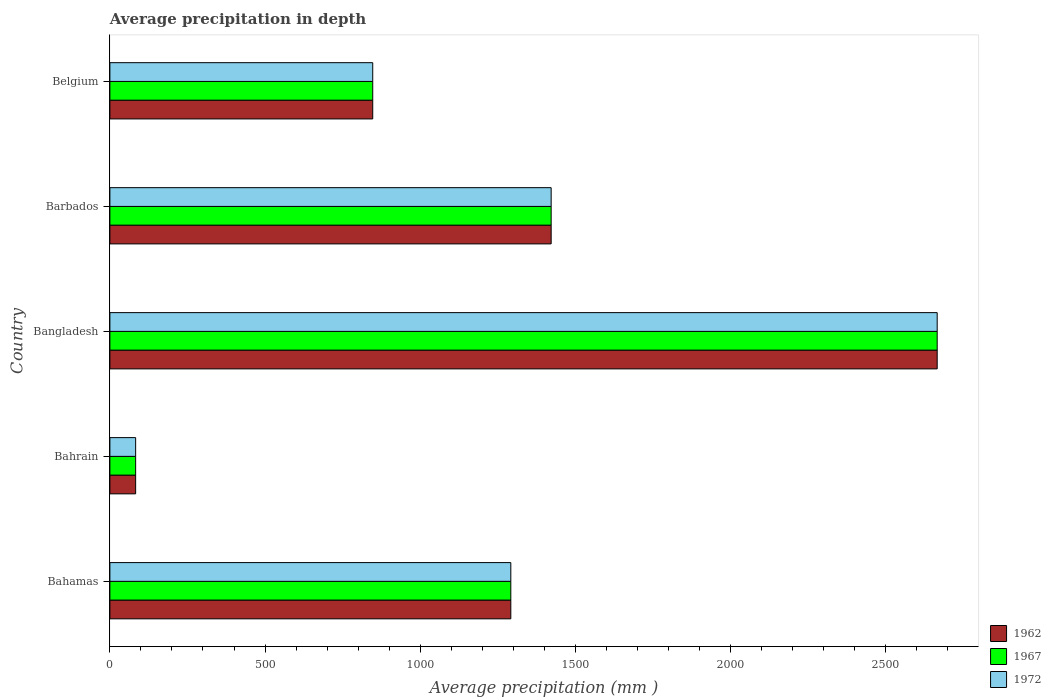How many different coloured bars are there?
Keep it short and to the point. 3. How many groups of bars are there?
Your response must be concise. 5. Are the number of bars on each tick of the Y-axis equal?
Your answer should be very brief. Yes. How many bars are there on the 2nd tick from the top?
Offer a very short reply. 3. How many bars are there on the 5th tick from the bottom?
Ensure brevity in your answer.  3. What is the label of the 5th group of bars from the top?
Your answer should be compact. Bahamas. In how many cases, is the number of bars for a given country not equal to the number of legend labels?
Offer a very short reply. 0. Across all countries, what is the maximum average precipitation in 1972?
Keep it short and to the point. 2666. Across all countries, what is the minimum average precipitation in 1972?
Provide a succinct answer. 83. In which country was the average precipitation in 1972 minimum?
Offer a very short reply. Bahrain. What is the total average precipitation in 1967 in the graph?
Make the answer very short. 6310. What is the difference between the average precipitation in 1962 in Bahamas and that in Belgium?
Your answer should be very brief. 445. What is the difference between the average precipitation in 1962 in Bangladesh and the average precipitation in 1972 in Bahamas?
Your response must be concise. 1374. What is the average average precipitation in 1967 per country?
Ensure brevity in your answer.  1262. What is the difference between the average precipitation in 1967 and average precipitation in 1972 in Bangladesh?
Offer a very short reply. 0. In how many countries, is the average precipitation in 1962 greater than 300 mm?
Your answer should be very brief. 4. What is the ratio of the average precipitation in 1962 in Barbados to that in Belgium?
Offer a terse response. 1.68. What is the difference between the highest and the second highest average precipitation in 1972?
Provide a short and direct response. 1244. What is the difference between the highest and the lowest average precipitation in 1962?
Provide a short and direct response. 2583. In how many countries, is the average precipitation in 1967 greater than the average average precipitation in 1967 taken over all countries?
Make the answer very short. 3. What does the 2nd bar from the top in Bahrain represents?
Give a very brief answer. 1967. What does the 1st bar from the bottom in Bangladesh represents?
Provide a short and direct response. 1962. How many bars are there?
Provide a short and direct response. 15. How many countries are there in the graph?
Give a very brief answer. 5. Does the graph contain grids?
Your answer should be very brief. No. Where does the legend appear in the graph?
Ensure brevity in your answer.  Bottom right. What is the title of the graph?
Make the answer very short. Average precipitation in depth. What is the label or title of the X-axis?
Ensure brevity in your answer.  Average precipitation (mm ). What is the label or title of the Y-axis?
Offer a terse response. Country. What is the Average precipitation (mm ) in 1962 in Bahamas?
Your response must be concise. 1292. What is the Average precipitation (mm ) of 1967 in Bahamas?
Make the answer very short. 1292. What is the Average precipitation (mm ) in 1972 in Bahamas?
Keep it short and to the point. 1292. What is the Average precipitation (mm ) of 1967 in Bahrain?
Offer a terse response. 83. What is the Average precipitation (mm ) in 1962 in Bangladesh?
Give a very brief answer. 2666. What is the Average precipitation (mm ) of 1967 in Bangladesh?
Keep it short and to the point. 2666. What is the Average precipitation (mm ) in 1972 in Bangladesh?
Ensure brevity in your answer.  2666. What is the Average precipitation (mm ) in 1962 in Barbados?
Give a very brief answer. 1422. What is the Average precipitation (mm ) in 1967 in Barbados?
Your answer should be very brief. 1422. What is the Average precipitation (mm ) in 1972 in Barbados?
Ensure brevity in your answer.  1422. What is the Average precipitation (mm ) in 1962 in Belgium?
Provide a short and direct response. 847. What is the Average precipitation (mm ) in 1967 in Belgium?
Ensure brevity in your answer.  847. What is the Average precipitation (mm ) of 1972 in Belgium?
Your response must be concise. 847. Across all countries, what is the maximum Average precipitation (mm ) in 1962?
Keep it short and to the point. 2666. Across all countries, what is the maximum Average precipitation (mm ) of 1967?
Provide a short and direct response. 2666. Across all countries, what is the maximum Average precipitation (mm ) of 1972?
Your answer should be compact. 2666. Across all countries, what is the minimum Average precipitation (mm ) of 1967?
Ensure brevity in your answer.  83. What is the total Average precipitation (mm ) in 1962 in the graph?
Offer a terse response. 6310. What is the total Average precipitation (mm ) of 1967 in the graph?
Keep it short and to the point. 6310. What is the total Average precipitation (mm ) in 1972 in the graph?
Offer a terse response. 6310. What is the difference between the Average precipitation (mm ) of 1962 in Bahamas and that in Bahrain?
Provide a succinct answer. 1209. What is the difference between the Average precipitation (mm ) of 1967 in Bahamas and that in Bahrain?
Keep it short and to the point. 1209. What is the difference between the Average precipitation (mm ) of 1972 in Bahamas and that in Bahrain?
Your answer should be compact. 1209. What is the difference between the Average precipitation (mm ) in 1962 in Bahamas and that in Bangladesh?
Offer a terse response. -1374. What is the difference between the Average precipitation (mm ) in 1967 in Bahamas and that in Bangladesh?
Your answer should be compact. -1374. What is the difference between the Average precipitation (mm ) of 1972 in Bahamas and that in Bangladesh?
Your answer should be very brief. -1374. What is the difference between the Average precipitation (mm ) in 1962 in Bahamas and that in Barbados?
Offer a very short reply. -130. What is the difference between the Average precipitation (mm ) of 1967 in Bahamas and that in Barbados?
Your answer should be compact. -130. What is the difference between the Average precipitation (mm ) in 1972 in Bahamas and that in Barbados?
Ensure brevity in your answer.  -130. What is the difference between the Average precipitation (mm ) in 1962 in Bahamas and that in Belgium?
Offer a very short reply. 445. What is the difference between the Average precipitation (mm ) of 1967 in Bahamas and that in Belgium?
Offer a very short reply. 445. What is the difference between the Average precipitation (mm ) in 1972 in Bahamas and that in Belgium?
Your answer should be compact. 445. What is the difference between the Average precipitation (mm ) of 1962 in Bahrain and that in Bangladesh?
Your response must be concise. -2583. What is the difference between the Average precipitation (mm ) in 1967 in Bahrain and that in Bangladesh?
Ensure brevity in your answer.  -2583. What is the difference between the Average precipitation (mm ) of 1972 in Bahrain and that in Bangladesh?
Your response must be concise. -2583. What is the difference between the Average precipitation (mm ) of 1962 in Bahrain and that in Barbados?
Your answer should be very brief. -1339. What is the difference between the Average precipitation (mm ) of 1967 in Bahrain and that in Barbados?
Keep it short and to the point. -1339. What is the difference between the Average precipitation (mm ) in 1972 in Bahrain and that in Barbados?
Provide a short and direct response. -1339. What is the difference between the Average precipitation (mm ) in 1962 in Bahrain and that in Belgium?
Provide a short and direct response. -764. What is the difference between the Average precipitation (mm ) of 1967 in Bahrain and that in Belgium?
Keep it short and to the point. -764. What is the difference between the Average precipitation (mm ) in 1972 in Bahrain and that in Belgium?
Give a very brief answer. -764. What is the difference between the Average precipitation (mm ) of 1962 in Bangladesh and that in Barbados?
Offer a very short reply. 1244. What is the difference between the Average precipitation (mm ) in 1967 in Bangladesh and that in Barbados?
Your response must be concise. 1244. What is the difference between the Average precipitation (mm ) of 1972 in Bangladesh and that in Barbados?
Your response must be concise. 1244. What is the difference between the Average precipitation (mm ) of 1962 in Bangladesh and that in Belgium?
Your response must be concise. 1819. What is the difference between the Average precipitation (mm ) of 1967 in Bangladesh and that in Belgium?
Keep it short and to the point. 1819. What is the difference between the Average precipitation (mm ) in 1972 in Bangladesh and that in Belgium?
Keep it short and to the point. 1819. What is the difference between the Average precipitation (mm ) in 1962 in Barbados and that in Belgium?
Provide a succinct answer. 575. What is the difference between the Average precipitation (mm ) in 1967 in Barbados and that in Belgium?
Give a very brief answer. 575. What is the difference between the Average precipitation (mm ) of 1972 in Barbados and that in Belgium?
Offer a terse response. 575. What is the difference between the Average precipitation (mm ) in 1962 in Bahamas and the Average precipitation (mm ) in 1967 in Bahrain?
Offer a very short reply. 1209. What is the difference between the Average precipitation (mm ) of 1962 in Bahamas and the Average precipitation (mm ) of 1972 in Bahrain?
Offer a very short reply. 1209. What is the difference between the Average precipitation (mm ) of 1967 in Bahamas and the Average precipitation (mm ) of 1972 in Bahrain?
Provide a short and direct response. 1209. What is the difference between the Average precipitation (mm ) in 1962 in Bahamas and the Average precipitation (mm ) in 1967 in Bangladesh?
Offer a very short reply. -1374. What is the difference between the Average precipitation (mm ) of 1962 in Bahamas and the Average precipitation (mm ) of 1972 in Bangladesh?
Ensure brevity in your answer.  -1374. What is the difference between the Average precipitation (mm ) in 1967 in Bahamas and the Average precipitation (mm ) in 1972 in Bangladesh?
Provide a succinct answer. -1374. What is the difference between the Average precipitation (mm ) in 1962 in Bahamas and the Average precipitation (mm ) in 1967 in Barbados?
Your answer should be compact. -130. What is the difference between the Average precipitation (mm ) in 1962 in Bahamas and the Average precipitation (mm ) in 1972 in Barbados?
Keep it short and to the point. -130. What is the difference between the Average precipitation (mm ) of 1967 in Bahamas and the Average precipitation (mm ) of 1972 in Barbados?
Keep it short and to the point. -130. What is the difference between the Average precipitation (mm ) in 1962 in Bahamas and the Average precipitation (mm ) in 1967 in Belgium?
Give a very brief answer. 445. What is the difference between the Average precipitation (mm ) of 1962 in Bahamas and the Average precipitation (mm ) of 1972 in Belgium?
Make the answer very short. 445. What is the difference between the Average precipitation (mm ) in 1967 in Bahamas and the Average precipitation (mm ) in 1972 in Belgium?
Offer a terse response. 445. What is the difference between the Average precipitation (mm ) in 1962 in Bahrain and the Average precipitation (mm ) in 1967 in Bangladesh?
Give a very brief answer. -2583. What is the difference between the Average precipitation (mm ) in 1962 in Bahrain and the Average precipitation (mm ) in 1972 in Bangladesh?
Your answer should be compact. -2583. What is the difference between the Average precipitation (mm ) in 1967 in Bahrain and the Average precipitation (mm ) in 1972 in Bangladesh?
Keep it short and to the point. -2583. What is the difference between the Average precipitation (mm ) of 1962 in Bahrain and the Average precipitation (mm ) of 1967 in Barbados?
Make the answer very short. -1339. What is the difference between the Average precipitation (mm ) in 1962 in Bahrain and the Average precipitation (mm ) in 1972 in Barbados?
Offer a very short reply. -1339. What is the difference between the Average precipitation (mm ) in 1967 in Bahrain and the Average precipitation (mm ) in 1972 in Barbados?
Your response must be concise. -1339. What is the difference between the Average precipitation (mm ) of 1962 in Bahrain and the Average precipitation (mm ) of 1967 in Belgium?
Give a very brief answer. -764. What is the difference between the Average precipitation (mm ) of 1962 in Bahrain and the Average precipitation (mm ) of 1972 in Belgium?
Offer a very short reply. -764. What is the difference between the Average precipitation (mm ) in 1967 in Bahrain and the Average precipitation (mm ) in 1972 in Belgium?
Offer a terse response. -764. What is the difference between the Average precipitation (mm ) in 1962 in Bangladesh and the Average precipitation (mm ) in 1967 in Barbados?
Provide a short and direct response. 1244. What is the difference between the Average precipitation (mm ) of 1962 in Bangladesh and the Average precipitation (mm ) of 1972 in Barbados?
Your answer should be compact. 1244. What is the difference between the Average precipitation (mm ) in 1967 in Bangladesh and the Average precipitation (mm ) in 1972 in Barbados?
Offer a terse response. 1244. What is the difference between the Average precipitation (mm ) in 1962 in Bangladesh and the Average precipitation (mm ) in 1967 in Belgium?
Ensure brevity in your answer.  1819. What is the difference between the Average precipitation (mm ) in 1962 in Bangladesh and the Average precipitation (mm ) in 1972 in Belgium?
Offer a terse response. 1819. What is the difference between the Average precipitation (mm ) of 1967 in Bangladesh and the Average precipitation (mm ) of 1972 in Belgium?
Ensure brevity in your answer.  1819. What is the difference between the Average precipitation (mm ) in 1962 in Barbados and the Average precipitation (mm ) in 1967 in Belgium?
Keep it short and to the point. 575. What is the difference between the Average precipitation (mm ) in 1962 in Barbados and the Average precipitation (mm ) in 1972 in Belgium?
Ensure brevity in your answer.  575. What is the difference between the Average precipitation (mm ) in 1967 in Barbados and the Average precipitation (mm ) in 1972 in Belgium?
Your response must be concise. 575. What is the average Average precipitation (mm ) of 1962 per country?
Offer a terse response. 1262. What is the average Average precipitation (mm ) in 1967 per country?
Ensure brevity in your answer.  1262. What is the average Average precipitation (mm ) in 1972 per country?
Your answer should be compact. 1262. What is the difference between the Average precipitation (mm ) of 1962 and Average precipitation (mm ) of 1967 in Bahamas?
Your answer should be very brief. 0. What is the difference between the Average precipitation (mm ) in 1962 and Average precipitation (mm ) in 1972 in Bahrain?
Ensure brevity in your answer.  0. What is the difference between the Average precipitation (mm ) of 1967 and Average precipitation (mm ) of 1972 in Bahrain?
Ensure brevity in your answer.  0. What is the difference between the Average precipitation (mm ) in 1962 and Average precipitation (mm ) in 1967 in Bangladesh?
Make the answer very short. 0. What is the difference between the Average precipitation (mm ) in 1962 and Average precipitation (mm ) in 1972 in Bangladesh?
Your response must be concise. 0. What is the difference between the Average precipitation (mm ) in 1962 and Average precipitation (mm ) in 1967 in Barbados?
Give a very brief answer. 0. What is the difference between the Average precipitation (mm ) of 1962 and Average precipitation (mm ) of 1972 in Barbados?
Provide a succinct answer. 0. What is the difference between the Average precipitation (mm ) in 1967 and Average precipitation (mm ) in 1972 in Barbados?
Give a very brief answer. 0. What is the difference between the Average precipitation (mm ) in 1967 and Average precipitation (mm ) in 1972 in Belgium?
Your answer should be very brief. 0. What is the ratio of the Average precipitation (mm ) of 1962 in Bahamas to that in Bahrain?
Make the answer very short. 15.57. What is the ratio of the Average precipitation (mm ) of 1967 in Bahamas to that in Bahrain?
Provide a succinct answer. 15.57. What is the ratio of the Average precipitation (mm ) of 1972 in Bahamas to that in Bahrain?
Make the answer very short. 15.57. What is the ratio of the Average precipitation (mm ) of 1962 in Bahamas to that in Bangladesh?
Make the answer very short. 0.48. What is the ratio of the Average precipitation (mm ) in 1967 in Bahamas to that in Bangladesh?
Your answer should be very brief. 0.48. What is the ratio of the Average precipitation (mm ) of 1972 in Bahamas to that in Bangladesh?
Give a very brief answer. 0.48. What is the ratio of the Average precipitation (mm ) of 1962 in Bahamas to that in Barbados?
Make the answer very short. 0.91. What is the ratio of the Average precipitation (mm ) in 1967 in Bahamas to that in Barbados?
Your response must be concise. 0.91. What is the ratio of the Average precipitation (mm ) in 1972 in Bahamas to that in Barbados?
Your answer should be compact. 0.91. What is the ratio of the Average precipitation (mm ) of 1962 in Bahamas to that in Belgium?
Offer a very short reply. 1.53. What is the ratio of the Average precipitation (mm ) of 1967 in Bahamas to that in Belgium?
Keep it short and to the point. 1.53. What is the ratio of the Average precipitation (mm ) of 1972 in Bahamas to that in Belgium?
Provide a short and direct response. 1.53. What is the ratio of the Average precipitation (mm ) in 1962 in Bahrain to that in Bangladesh?
Keep it short and to the point. 0.03. What is the ratio of the Average precipitation (mm ) of 1967 in Bahrain to that in Bangladesh?
Your answer should be compact. 0.03. What is the ratio of the Average precipitation (mm ) of 1972 in Bahrain to that in Bangladesh?
Offer a very short reply. 0.03. What is the ratio of the Average precipitation (mm ) in 1962 in Bahrain to that in Barbados?
Your answer should be compact. 0.06. What is the ratio of the Average precipitation (mm ) in 1967 in Bahrain to that in Barbados?
Offer a terse response. 0.06. What is the ratio of the Average precipitation (mm ) of 1972 in Bahrain to that in Barbados?
Your answer should be compact. 0.06. What is the ratio of the Average precipitation (mm ) of 1962 in Bahrain to that in Belgium?
Give a very brief answer. 0.1. What is the ratio of the Average precipitation (mm ) of 1967 in Bahrain to that in Belgium?
Your answer should be very brief. 0.1. What is the ratio of the Average precipitation (mm ) in 1972 in Bahrain to that in Belgium?
Keep it short and to the point. 0.1. What is the ratio of the Average precipitation (mm ) in 1962 in Bangladesh to that in Barbados?
Offer a very short reply. 1.87. What is the ratio of the Average precipitation (mm ) in 1967 in Bangladesh to that in Barbados?
Keep it short and to the point. 1.87. What is the ratio of the Average precipitation (mm ) of 1972 in Bangladesh to that in Barbados?
Keep it short and to the point. 1.87. What is the ratio of the Average precipitation (mm ) of 1962 in Bangladesh to that in Belgium?
Offer a terse response. 3.15. What is the ratio of the Average precipitation (mm ) of 1967 in Bangladesh to that in Belgium?
Your response must be concise. 3.15. What is the ratio of the Average precipitation (mm ) of 1972 in Bangladesh to that in Belgium?
Give a very brief answer. 3.15. What is the ratio of the Average precipitation (mm ) of 1962 in Barbados to that in Belgium?
Your answer should be compact. 1.68. What is the ratio of the Average precipitation (mm ) of 1967 in Barbados to that in Belgium?
Ensure brevity in your answer.  1.68. What is the ratio of the Average precipitation (mm ) in 1972 in Barbados to that in Belgium?
Your response must be concise. 1.68. What is the difference between the highest and the second highest Average precipitation (mm ) of 1962?
Ensure brevity in your answer.  1244. What is the difference between the highest and the second highest Average precipitation (mm ) in 1967?
Keep it short and to the point. 1244. What is the difference between the highest and the second highest Average precipitation (mm ) in 1972?
Your response must be concise. 1244. What is the difference between the highest and the lowest Average precipitation (mm ) of 1962?
Your answer should be compact. 2583. What is the difference between the highest and the lowest Average precipitation (mm ) in 1967?
Provide a short and direct response. 2583. What is the difference between the highest and the lowest Average precipitation (mm ) of 1972?
Offer a terse response. 2583. 